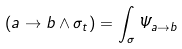<formula> <loc_0><loc_0><loc_500><loc_500>( a \rightarrow b \wedge \sigma _ { t } ) = \int _ { \sigma } \Psi _ { a \rightarrow b }</formula> 